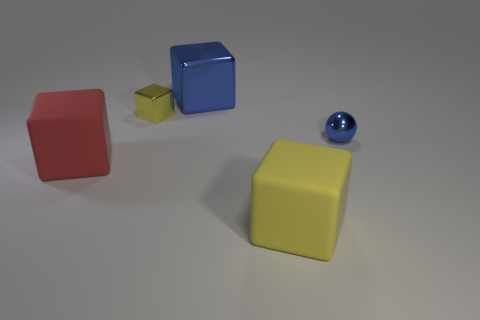There is a blue metallic thing that is behind the tiny thing on the left side of the large metal object; what size is it?
Offer a terse response. Large. What is the color of the ball?
Offer a very short reply. Blue. There is a big rubber block to the left of the large blue metal object; how many red objects are in front of it?
Offer a terse response. 0. Is there a blue object that is to the left of the blue metal object that is on the left side of the small blue metal ball?
Your answer should be very brief. No. There is a big yellow matte block; are there any large objects in front of it?
Your answer should be compact. No. There is a big thing on the right side of the large metallic block; is it the same shape as the yellow shiny thing?
Give a very brief answer. Yes. How many yellow rubber things are the same shape as the big red rubber thing?
Your response must be concise. 1. Are there any cyan objects made of the same material as the big yellow object?
Your answer should be compact. No. There is a red cube on the left side of the yellow cube in front of the big red matte block; what is it made of?
Ensure brevity in your answer.  Rubber. How big is the matte cube that is right of the small yellow object?
Make the answer very short. Large. 